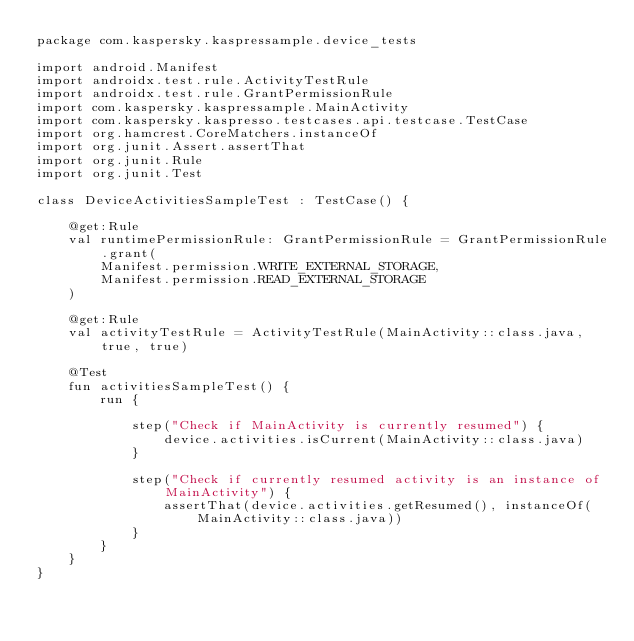Convert code to text. <code><loc_0><loc_0><loc_500><loc_500><_Kotlin_>package com.kaspersky.kaspressample.device_tests

import android.Manifest
import androidx.test.rule.ActivityTestRule
import androidx.test.rule.GrantPermissionRule
import com.kaspersky.kaspressample.MainActivity
import com.kaspersky.kaspresso.testcases.api.testcase.TestCase
import org.hamcrest.CoreMatchers.instanceOf
import org.junit.Assert.assertThat
import org.junit.Rule
import org.junit.Test

class DeviceActivitiesSampleTest : TestCase() {

    @get:Rule
    val runtimePermissionRule: GrantPermissionRule = GrantPermissionRule.grant(
        Manifest.permission.WRITE_EXTERNAL_STORAGE,
        Manifest.permission.READ_EXTERNAL_STORAGE
    )

    @get:Rule
    val activityTestRule = ActivityTestRule(MainActivity::class.java, true, true)

    @Test
    fun activitiesSampleTest() {
        run {

            step("Check if MainActivity is currently resumed") {
                device.activities.isCurrent(MainActivity::class.java)
            }

            step("Check if currently resumed activity is an instance of MainActivity") {
                assertThat(device.activities.getResumed(), instanceOf(MainActivity::class.java))
            }
        }
    }
}</code> 